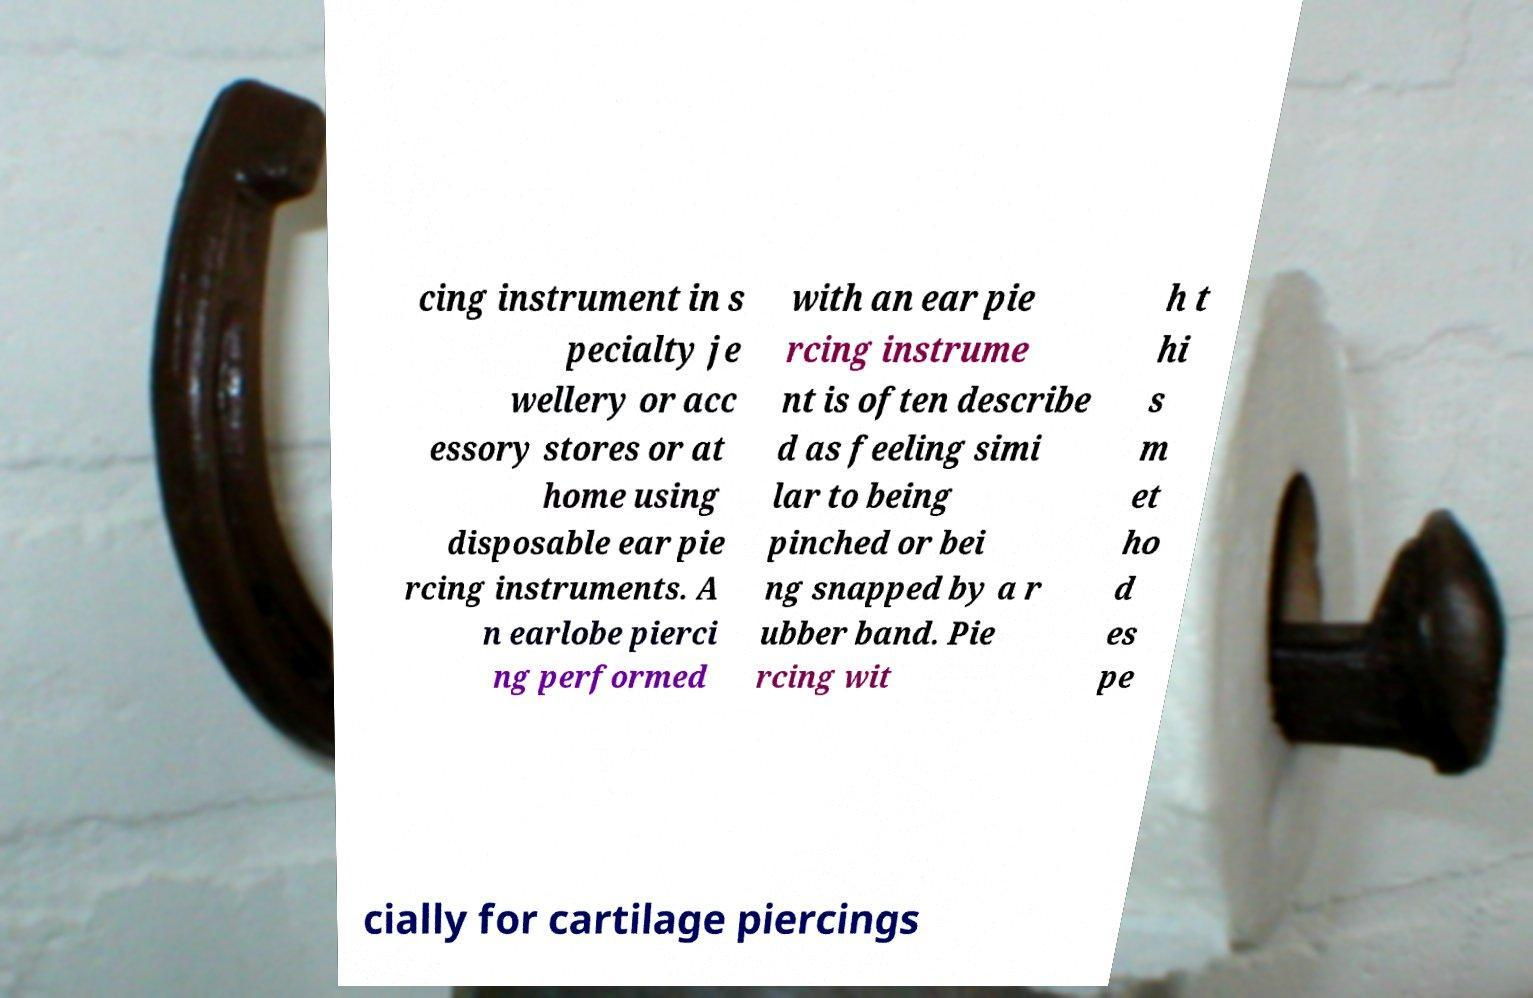Can you read and provide the text displayed in the image?This photo seems to have some interesting text. Can you extract and type it out for me? cing instrument in s pecialty je wellery or acc essory stores or at home using disposable ear pie rcing instruments. A n earlobe pierci ng performed with an ear pie rcing instrume nt is often describe d as feeling simi lar to being pinched or bei ng snapped by a r ubber band. Pie rcing wit h t hi s m et ho d es pe cially for cartilage piercings 